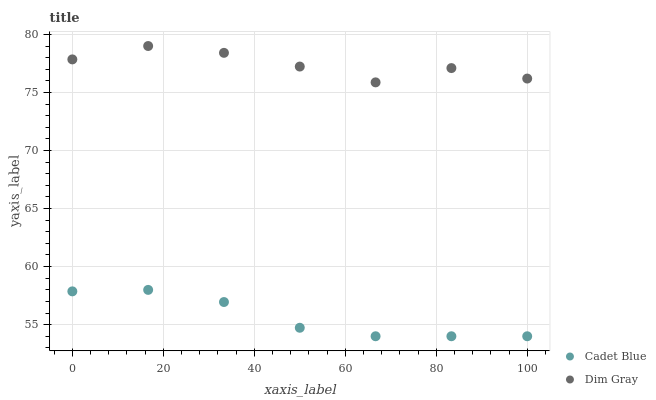Does Cadet Blue have the minimum area under the curve?
Answer yes or no. Yes. Does Dim Gray have the maximum area under the curve?
Answer yes or no. Yes. Does Cadet Blue have the maximum area under the curve?
Answer yes or no. No. Is Cadet Blue the smoothest?
Answer yes or no. Yes. Is Dim Gray the roughest?
Answer yes or no. Yes. Is Cadet Blue the roughest?
Answer yes or no. No. Does Cadet Blue have the lowest value?
Answer yes or no. Yes. Does Dim Gray have the highest value?
Answer yes or no. Yes. Does Cadet Blue have the highest value?
Answer yes or no. No. Is Cadet Blue less than Dim Gray?
Answer yes or no. Yes. Is Dim Gray greater than Cadet Blue?
Answer yes or no. Yes. Does Cadet Blue intersect Dim Gray?
Answer yes or no. No. 